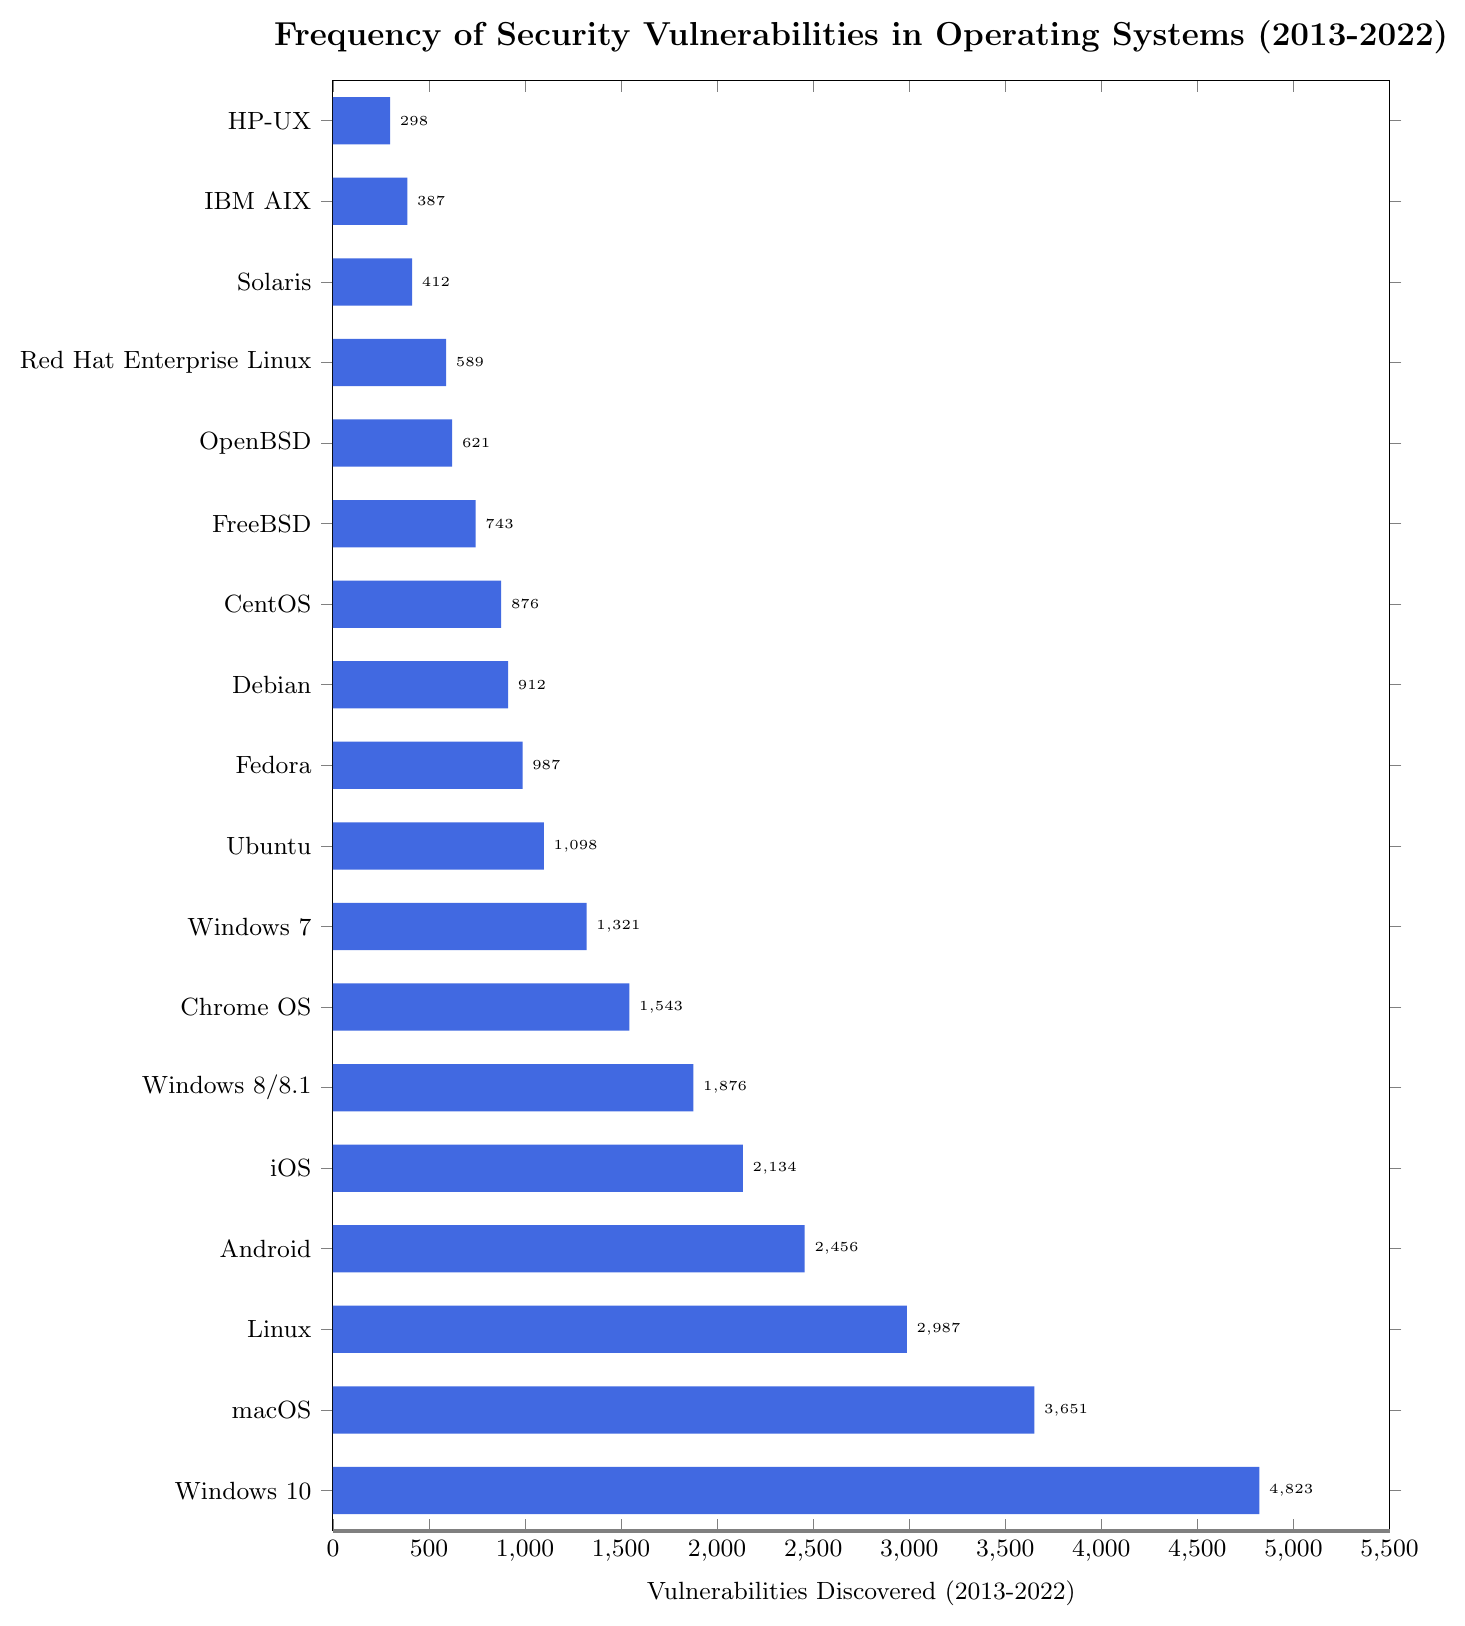Which operating system has the highest number of discovered vulnerabilities? By referring to the bar chart, we can see that Windows 10 has the tallest bar, indicating it has the highest number of discovered vulnerabilities.
Answer: Windows 10 Which operating system has fewer vulnerabilities discovered: macOS or Linux? By comparing the lengths of the bars for macOS and Linux, we can see that the bar for Linux is shorter than the one for macOS. Therefore, Linux has fewer vulnerabilities discovered.
Answer: Linux How many more vulnerabilities were discovered in Windows 10 compared to Ubuntu? Referring to the bar values, Windows 10 has 4823 vulnerabilities, while Ubuntu has 1098. The difference is calculated as 4823 - 1098 = 3725.
Answer: 3725 What is the total number of vulnerabilities discovered for all versions of Windows combined (Windows 10, Windows 8/8.1, Windows 7)? Summing up the vulnerabilities for Windows 10 (4823), Windows 8/8.1 (1876), and Windows 7 (1321), we get 4823 + 1876 + 1321 = 8019.
Answer: 8019 Which operating system has the least number of discovered vulnerabilities? The shortest bar in the chart corresponds to HP-UX, indicating it has the least number of discovered vulnerabilities.
Answer: HP-UX What is the average number of vulnerabilities discovered across all operating systems displayed? First, sum up the vulnerabilities: 4823 (Windows 10) + 3651 (macOS) + 2987 (Linux) + 2456 (Android) + 2134 (iOS) + 1876 (Windows 8/8.1) + 1543 (Chrome OS) + 1321 (Windows 7) + 1098 (Ubuntu) + 987 (Fedora) + 912 (Debian) + 876 (CentOS) + 743 (FreeBSD) + 621 (OpenBSD) + 589 (Red Hat Enterprise Linux) + 412 (Solaris) + 387 (IBM AIX) + 298 (HP-UX) = 31713. Then, divide by the number of operating systems (18): 31713 / 18 ≈ 1762.
Answer: 1762 How does the number of vulnerabilities discovered in Chrome OS compare to that in Android? The bar for Android is longer with 2456 vulnerabilities, whereas Chrome OS has 1543. Android has more vulnerabilities discovered than Chrome OS.
Answer: Android has more What is the combined total of vulnerabilities discovered for FreeBSD and OpenBSD? FreeBSD has 743 vulnerabilities and OpenBSD has 621. Adding them together, 743 + 621 = 1364.
Answer: 1364 By how much does the number of vulnerabilities discovered in Android exceed those in iOS? Android has 2456 vulnerabilities, and iOS has 2134. The difference is calculated as 2456 - 2134 = 322.
Answer: 322 What is the rank of Red Hat Enterprise Linux in terms of the number of vulnerabilities discovered, from highest to lowest? By looking at the bar lengths and counting, Red Hat Enterprise Linux appears after many other operating systems but before Solaris and IBM AIX, placing it 14th in the order.
Answer: 14th 